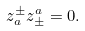Convert formula to latex. <formula><loc_0><loc_0><loc_500><loc_500>z _ { a } ^ { \pm } z _ { \pm } ^ { a } = 0 .</formula> 